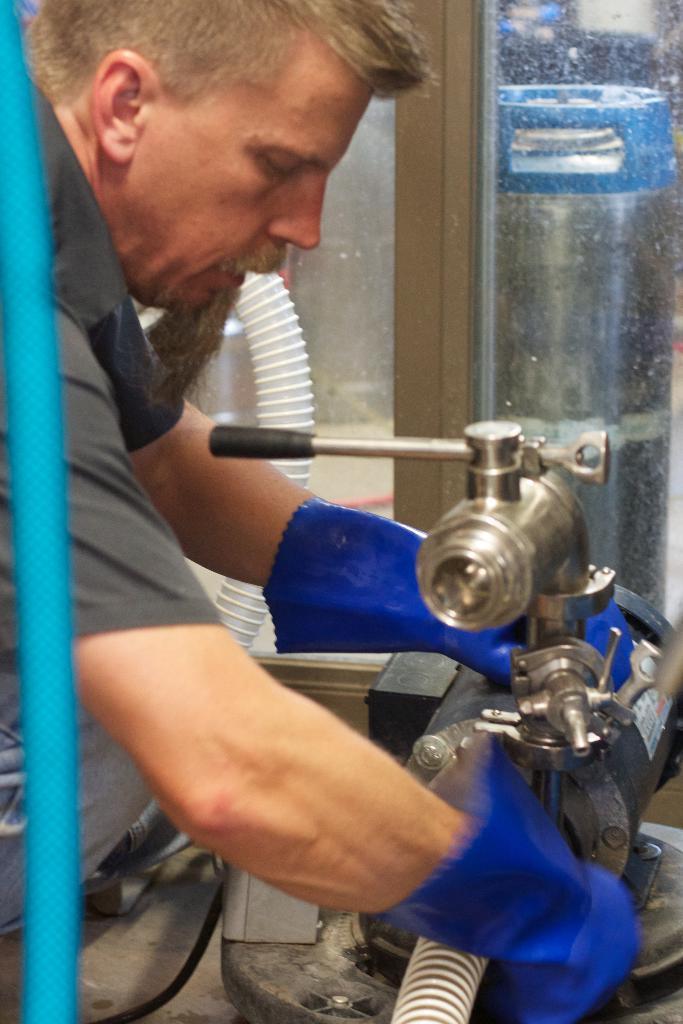Can you describe this image briefly? In this image in the center there is a person, working on a machine which is in front of him. 